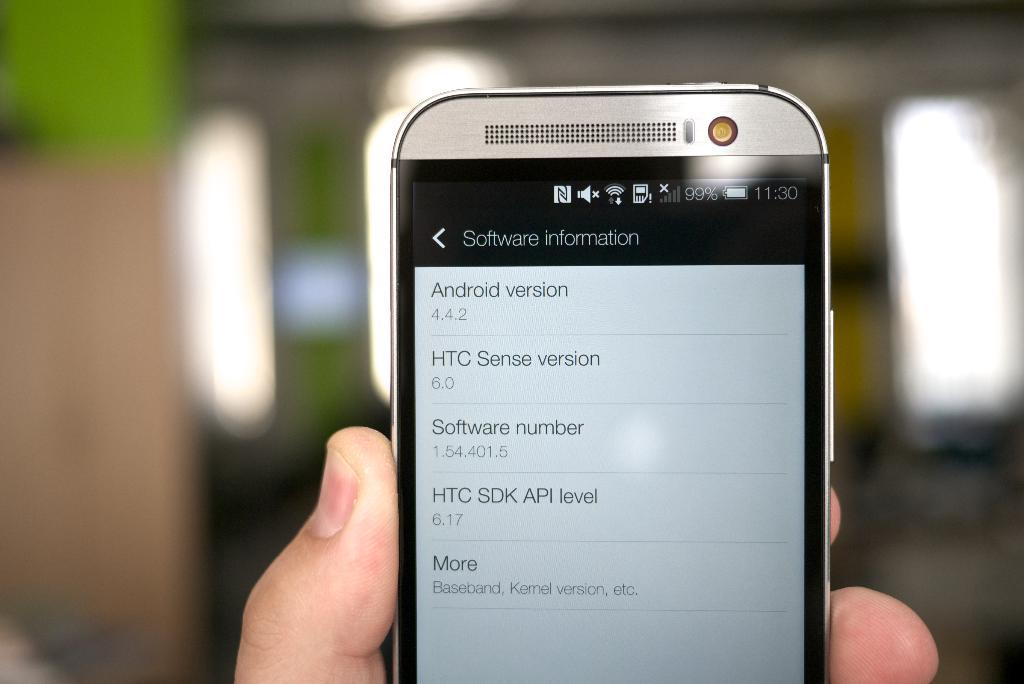What is the person in the image holding? The person is holding a mobile phone in the image. What can be seen on the mobile phone's screen? The mobile phone has text displayed on it. What can be seen in the background of the image? There are lights visible in the background of the image. What direction are the person's eyes looking in the image? The image does not show the person's eyes, so it is not possible to determine the direction they are looking. Can you describe the ocean in the image? There is no ocean present in the image. 